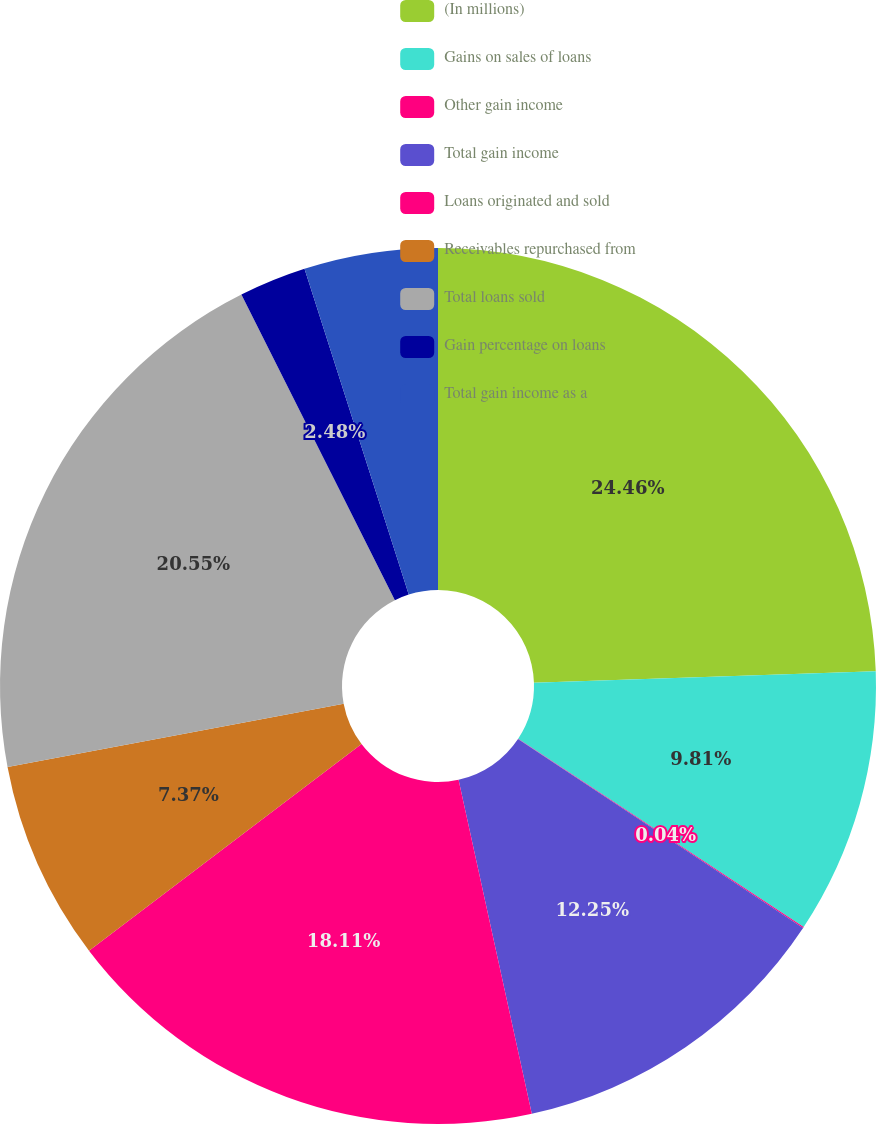Convert chart to OTSL. <chart><loc_0><loc_0><loc_500><loc_500><pie_chart><fcel>(In millions)<fcel>Gains on sales of loans<fcel>Other gain income<fcel>Total gain income<fcel>Loans originated and sold<fcel>Receivables repurchased from<fcel>Total loans sold<fcel>Gain percentage on loans<fcel>Total gain income as a<nl><fcel>24.47%<fcel>9.81%<fcel>0.04%<fcel>12.25%<fcel>18.11%<fcel>7.37%<fcel>20.55%<fcel>2.48%<fcel>4.93%<nl></chart> 